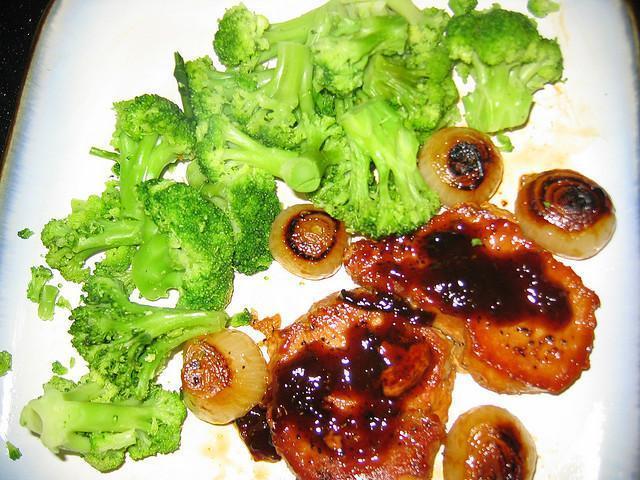How many broccolis are there?
Give a very brief answer. 4. 